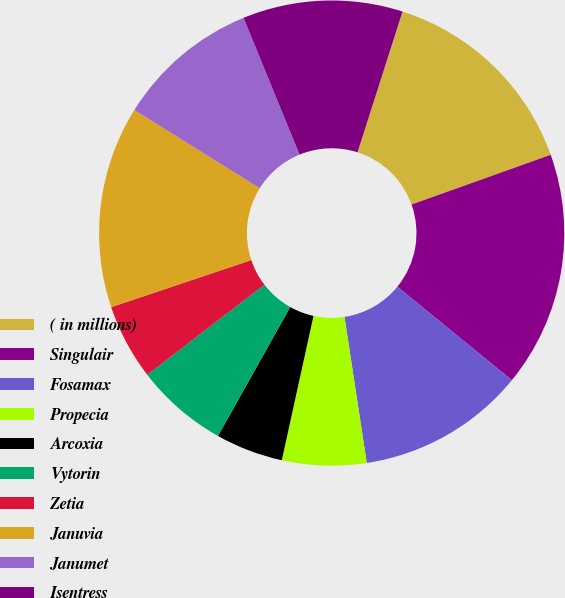<chart> <loc_0><loc_0><loc_500><loc_500><pie_chart><fcel>( in millions)<fcel>Singulair<fcel>Fosamax<fcel>Propecia<fcel>Arcoxia<fcel>Vytorin<fcel>Zetia<fcel>Januvia<fcel>Janumet<fcel>Isentress<nl><fcel>14.61%<fcel>16.36%<fcel>11.69%<fcel>5.85%<fcel>4.69%<fcel>6.44%<fcel>5.27%<fcel>14.03%<fcel>9.94%<fcel>11.11%<nl></chart> 